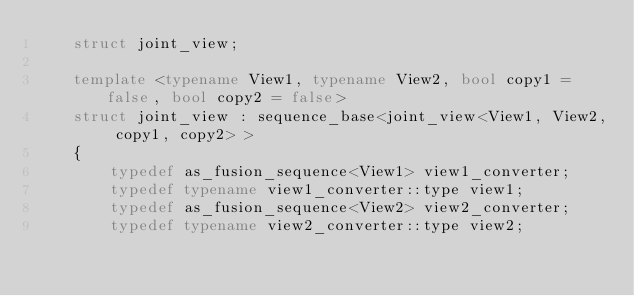Convert code to text. <code><loc_0><loc_0><loc_500><loc_500><_C++_>    struct joint_view;

    template <typename View1, typename View2, bool copy1 = false, bool copy2 = false>
    struct joint_view : sequence_base<joint_view<View1, View2, copy1, copy2> >
    {
        typedef as_fusion_sequence<View1> view1_converter;
        typedef typename view1_converter::type view1;
        typedef as_fusion_sequence<View2> view2_converter;
        typedef typename view2_converter::type view2;
</code> 